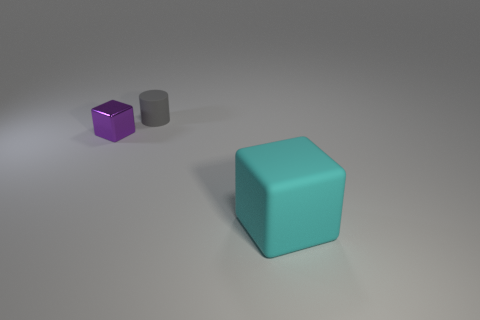Add 1 purple objects. How many objects exist? 4 Subtract all cylinders. How many objects are left? 2 Subtract 1 blocks. How many blocks are left? 1 Subtract all green blocks. Subtract all yellow spheres. How many blocks are left? 2 Subtract all blue spheres. How many cyan cylinders are left? 0 Subtract all purple shiny objects. Subtract all cyan matte things. How many objects are left? 1 Add 1 big objects. How many big objects are left? 2 Add 3 large brown balls. How many large brown balls exist? 3 Subtract 1 purple cubes. How many objects are left? 2 